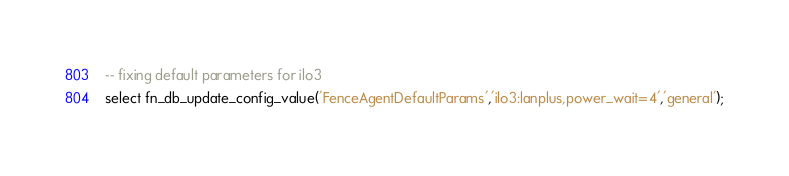<code> <loc_0><loc_0><loc_500><loc_500><_SQL_>-- fixing default parameters for ilo3
select fn_db_update_config_value('FenceAgentDefaultParams','ilo3:lanplus,power_wait=4','general');
</code> 